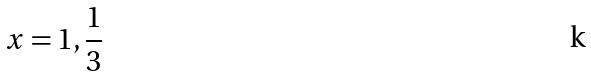Convert formula to latex. <formula><loc_0><loc_0><loc_500><loc_500>x = 1 , \frac { 1 } { 3 }</formula> 